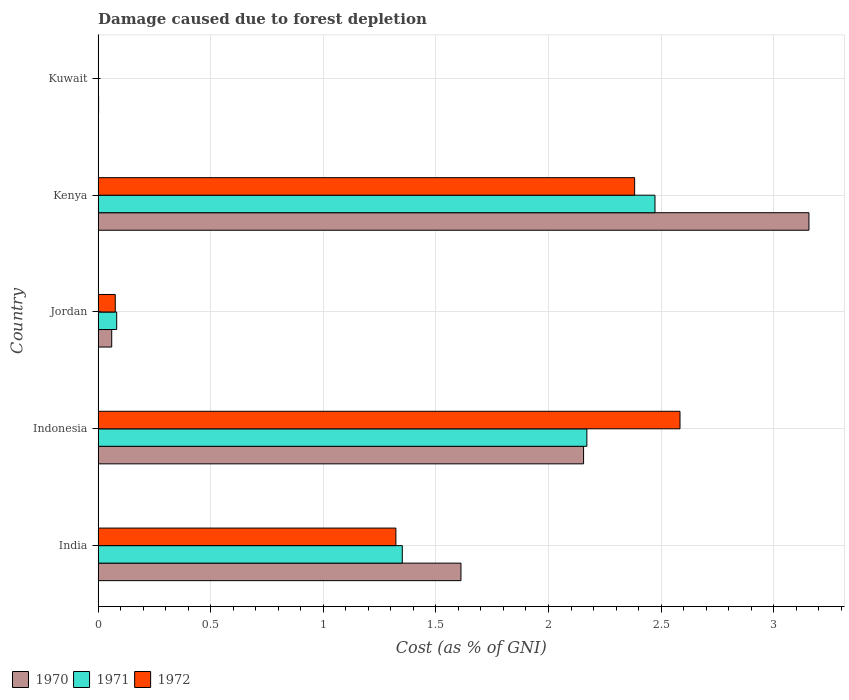How many different coloured bars are there?
Your answer should be very brief. 3. How many groups of bars are there?
Give a very brief answer. 5. Are the number of bars per tick equal to the number of legend labels?
Your answer should be very brief. Yes. Are the number of bars on each tick of the Y-axis equal?
Ensure brevity in your answer.  Yes. What is the label of the 2nd group of bars from the top?
Give a very brief answer. Kenya. What is the cost of damage caused due to forest depletion in 1971 in India?
Your answer should be very brief. 1.35. Across all countries, what is the maximum cost of damage caused due to forest depletion in 1972?
Give a very brief answer. 2.58. Across all countries, what is the minimum cost of damage caused due to forest depletion in 1971?
Your answer should be very brief. 0. In which country was the cost of damage caused due to forest depletion in 1970 maximum?
Provide a succinct answer. Kenya. In which country was the cost of damage caused due to forest depletion in 1971 minimum?
Offer a very short reply. Kuwait. What is the total cost of damage caused due to forest depletion in 1970 in the graph?
Your answer should be very brief. 6.99. What is the difference between the cost of damage caused due to forest depletion in 1972 in Jordan and that in Kuwait?
Your answer should be very brief. 0.07. What is the difference between the cost of damage caused due to forest depletion in 1971 in Kuwait and the cost of damage caused due to forest depletion in 1970 in Indonesia?
Offer a very short reply. -2.15. What is the average cost of damage caused due to forest depletion in 1972 per country?
Provide a succinct answer. 1.27. What is the difference between the cost of damage caused due to forest depletion in 1970 and cost of damage caused due to forest depletion in 1971 in Kuwait?
Ensure brevity in your answer.  0. What is the ratio of the cost of damage caused due to forest depletion in 1970 in India to that in Kenya?
Ensure brevity in your answer.  0.51. Is the cost of damage caused due to forest depletion in 1970 in Indonesia less than that in Jordan?
Provide a short and direct response. No. Is the difference between the cost of damage caused due to forest depletion in 1970 in Jordan and Kuwait greater than the difference between the cost of damage caused due to forest depletion in 1971 in Jordan and Kuwait?
Provide a short and direct response. No. What is the difference between the highest and the second highest cost of damage caused due to forest depletion in 1972?
Give a very brief answer. 0.2. What is the difference between the highest and the lowest cost of damage caused due to forest depletion in 1970?
Offer a terse response. 3.15. In how many countries, is the cost of damage caused due to forest depletion in 1970 greater than the average cost of damage caused due to forest depletion in 1970 taken over all countries?
Offer a terse response. 3. What does the 1st bar from the top in Kenya represents?
Keep it short and to the point. 1972. What does the 3rd bar from the bottom in Indonesia represents?
Offer a very short reply. 1972. How many bars are there?
Provide a short and direct response. 15. How many countries are there in the graph?
Offer a terse response. 5. Does the graph contain any zero values?
Keep it short and to the point. No. Does the graph contain grids?
Your answer should be very brief. Yes. Where does the legend appear in the graph?
Offer a very short reply. Bottom left. How many legend labels are there?
Provide a succinct answer. 3. What is the title of the graph?
Your answer should be compact. Damage caused due to forest depletion. What is the label or title of the X-axis?
Offer a terse response. Cost (as % of GNI). What is the label or title of the Y-axis?
Provide a succinct answer. Country. What is the Cost (as % of GNI) of 1970 in India?
Your answer should be compact. 1.61. What is the Cost (as % of GNI) of 1971 in India?
Your answer should be compact. 1.35. What is the Cost (as % of GNI) of 1972 in India?
Provide a short and direct response. 1.32. What is the Cost (as % of GNI) in 1970 in Indonesia?
Your answer should be compact. 2.16. What is the Cost (as % of GNI) in 1971 in Indonesia?
Offer a terse response. 2.17. What is the Cost (as % of GNI) in 1972 in Indonesia?
Offer a very short reply. 2.58. What is the Cost (as % of GNI) in 1970 in Jordan?
Your answer should be compact. 0.06. What is the Cost (as % of GNI) in 1971 in Jordan?
Your answer should be very brief. 0.08. What is the Cost (as % of GNI) of 1972 in Jordan?
Make the answer very short. 0.08. What is the Cost (as % of GNI) in 1970 in Kenya?
Provide a short and direct response. 3.16. What is the Cost (as % of GNI) in 1971 in Kenya?
Provide a succinct answer. 2.47. What is the Cost (as % of GNI) of 1972 in Kenya?
Provide a short and direct response. 2.38. What is the Cost (as % of GNI) of 1970 in Kuwait?
Ensure brevity in your answer.  0. What is the Cost (as % of GNI) of 1971 in Kuwait?
Your response must be concise. 0. What is the Cost (as % of GNI) in 1972 in Kuwait?
Provide a short and direct response. 0. Across all countries, what is the maximum Cost (as % of GNI) in 1970?
Keep it short and to the point. 3.16. Across all countries, what is the maximum Cost (as % of GNI) of 1971?
Offer a terse response. 2.47. Across all countries, what is the maximum Cost (as % of GNI) of 1972?
Give a very brief answer. 2.58. Across all countries, what is the minimum Cost (as % of GNI) in 1970?
Ensure brevity in your answer.  0. Across all countries, what is the minimum Cost (as % of GNI) of 1971?
Offer a terse response. 0. Across all countries, what is the minimum Cost (as % of GNI) of 1972?
Make the answer very short. 0. What is the total Cost (as % of GNI) of 1970 in the graph?
Keep it short and to the point. 6.99. What is the total Cost (as % of GNI) in 1971 in the graph?
Offer a very short reply. 6.08. What is the total Cost (as % of GNI) in 1972 in the graph?
Provide a short and direct response. 6.37. What is the difference between the Cost (as % of GNI) in 1970 in India and that in Indonesia?
Your answer should be compact. -0.54. What is the difference between the Cost (as % of GNI) of 1971 in India and that in Indonesia?
Your answer should be very brief. -0.82. What is the difference between the Cost (as % of GNI) of 1972 in India and that in Indonesia?
Offer a terse response. -1.26. What is the difference between the Cost (as % of GNI) of 1970 in India and that in Jordan?
Your answer should be very brief. 1.55. What is the difference between the Cost (as % of GNI) of 1971 in India and that in Jordan?
Your answer should be compact. 1.27. What is the difference between the Cost (as % of GNI) of 1972 in India and that in Jordan?
Offer a very short reply. 1.25. What is the difference between the Cost (as % of GNI) in 1970 in India and that in Kenya?
Offer a terse response. -1.55. What is the difference between the Cost (as % of GNI) in 1971 in India and that in Kenya?
Make the answer very short. -1.12. What is the difference between the Cost (as % of GNI) of 1972 in India and that in Kenya?
Make the answer very short. -1.06. What is the difference between the Cost (as % of GNI) of 1970 in India and that in Kuwait?
Your answer should be very brief. 1.61. What is the difference between the Cost (as % of GNI) in 1971 in India and that in Kuwait?
Your answer should be very brief. 1.35. What is the difference between the Cost (as % of GNI) in 1972 in India and that in Kuwait?
Provide a succinct answer. 1.32. What is the difference between the Cost (as % of GNI) of 1970 in Indonesia and that in Jordan?
Ensure brevity in your answer.  2.1. What is the difference between the Cost (as % of GNI) of 1971 in Indonesia and that in Jordan?
Provide a succinct answer. 2.09. What is the difference between the Cost (as % of GNI) in 1972 in Indonesia and that in Jordan?
Make the answer very short. 2.51. What is the difference between the Cost (as % of GNI) of 1970 in Indonesia and that in Kenya?
Ensure brevity in your answer.  -1. What is the difference between the Cost (as % of GNI) in 1971 in Indonesia and that in Kenya?
Keep it short and to the point. -0.3. What is the difference between the Cost (as % of GNI) of 1972 in Indonesia and that in Kenya?
Your answer should be very brief. 0.2. What is the difference between the Cost (as % of GNI) in 1970 in Indonesia and that in Kuwait?
Offer a very short reply. 2.15. What is the difference between the Cost (as % of GNI) in 1971 in Indonesia and that in Kuwait?
Offer a very short reply. 2.17. What is the difference between the Cost (as % of GNI) of 1972 in Indonesia and that in Kuwait?
Offer a terse response. 2.58. What is the difference between the Cost (as % of GNI) in 1970 in Jordan and that in Kenya?
Provide a short and direct response. -3.1. What is the difference between the Cost (as % of GNI) of 1971 in Jordan and that in Kenya?
Provide a short and direct response. -2.39. What is the difference between the Cost (as % of GNI) in 1972 in Jordan and that in Kenya?
Keep it short and to the point. -2.31. What is the difference between the Cost (as % of GNI) in 1970 in Jordan and that in Kuwait?
Your answer should be compact. 0.06. What is the difference between the Cost (as % of GNI) of 1971 in Jordan and that in Kuwait?
Give a very brief answer. 0.08. What is the difference between the Cost (as % of GNI) in 1972 in Jordan and that in Kuwait?
Provide a short and direct response. 0.07. What is the difference between the Cost (as % of GNI) in 1970 in Kenya and that in Kuwait?
Your answer should be compact. 3.15. What is the difference between the Cost (as % of GNI) of 1971 in Kenya and that in Kuwait?
Your answer should be very brief. 2.47. What is the difference between the Cost (as % of GNI) in 1972 in Kenya and that in Kuwait?
Offer a very short reply. 2.38. What is the difference between the Cost (as % of GNI) of 1970 in India and the Cost (as % of GNI) of 1971 in Indonesia?
Provide a succinct answer. -0.56. What is the difference between the Cost (as % of GNI) of 1970 in India and the Cost (as % of GNI) of 1972 in Indonesia?
Provide a succinct answer. -0.97. What is the difference between the Cost (as % of GNI) of 1971 in India and the Cost (as % of GNI) of 1972 in Indonesia?
Keep it short and to the point. -1.23. What is the difference between the Cost (as % of GNI) in 1970 in India and the Cost (as % of GNI) in 1971 in Jordan?
Offer a very short reply. 1.53. What is the difference between the Cost (as % of GNI) of 1970 in India and the Cost (as % of GNI) of 1972 in Jordan?
Your answer should be compact. 1.54. What is the difference between the Cost (as % of GNI) in 1971 in India and the Cost (as % of GNI) in 1972 in Jordan?
Offer a very short reply. 1.27. What is the difference between the Cost (as % of GNI) in 1970 in India and the Cost (as % of GNI) in 1971 in Kenya?
Your response must be concise. -0.86. What is the difference between the Cost (as % of GNI) of 1970 in India and the Cost (as % of GNI) of 1972 in Kenya?
Offer a very short reply. -0.77. What is the difference between the Cost (as % of GNI) of 1971 in India and the Cost (as % of GNI) of 1972 in Kenya?
Provide a short and direct response. -1.03. What is the difference between the Cost (as % of GNI) in 1970 in India and the Cost (as % of GNI) in 1971 in Kuwait?
Ensure brevity in your answer.  1.61. What is the difference between the Cost (as % of GNI) in 1970 in India and the Cost (as % of GNI) in 1972 in Kuwait?
Keep it short and to the point. 1.61. What is the difference between the Cost (as % of GNI) of 1971 in India and the Cost (as % of GNI) of 1972 in Kuwait?
Keep it short and to the point. 1.35. What is the difference between the Cost (as % of GNI) of 1970 in Indonesia and the Cost (as % of GNI) of 1971 in Jordan?
Your answer should be very brief. 2.07. What is the difference between the Cost (as % of GNI) of 1970 in Indonesia and the Cost (as % of GNI) of 1972 in Jordan?
Make the answer very short. 2.08. What is the difference between the Cost (as % of GNI) of 1971 in Indonesia and the Cost (as % of GNI) of 1972 in Jordan?
Make the answer very short. 2.09. What is the difference between the Cost (as % of GNI) of 1970 in Indonesia and the Cost (as % of GNI) of 1971 in Kenya?
Provide a short and direct response. -0.32. What is the difference between the Cost (as % of GNI) of 1970 in Indonesia and the Cost (as % of GNI) of 1972 in Kenya?
Ensure brevity in your answer.  -0.23. What is the difference between the Cost (as % of GNI) of 1971 in Indonesia and the Cost (as % of GNI) of 1972 in Kenya?
Your response must be concise. -0.21. What is the difference between the Cost (as % of GNI) of 1970 in Indonesia and the Cost (as % of GNI) of 1971 in Kuwait?
Your response must be concise. 2.15. What is the difference between the Cost (as % of GNI) in 1970 in Indonesia and the Cost (as % of GNI) in 1972 in Kuwait?
Your answer should be compact. 2.15. What is the difference between the Cost (as % of GNI) in 1971 in Indonesia and the Cost (as % of GNI) in 1972 in Kuwait?
Ensure brevity in your answer.  2.17. What is the difference between the Cost (as % of GNI) of 1970 in Jordan and the Cost (as % of GNI) of 1971 in Kenya?
Keep it short and to the point. -2.41. What is the difference between the Cost (as % of GNI) in 1970 in Jordan and the Cost (as % of GNI) in 1972 in Kenya?
Provide a short and direct response. -2.32. What is the difference between the Cost (as % of GNI) of 1971 in Jordan and the Cost (as % of GNI) of 1972 in Kenya?
Provide a short and direct response. -2.3. What is the difference between the Cost (as % of GNI) of 1970 in Jordan and the Cost (as % of GNI) of 1971 in Kuwait?
Ensure brevity in your answer.  0.06. What is the difference between the Cost (as % of GNI) of 1970 in Jordan and the Cost (as % of GNI) of 1972 in Kuwait?
Your answer should be very brief. 0.06. What is the difference between the Cost (as % of GNI) in 1971 in Jordan and the Cost (as % of GNI) in 1972 in Kuwait?
Provide a short and direct response. 0.08. What is the difference between the Cost (as % of GNI) of 1970 in Kenya and the Cost (as % of GNI) of 1971 in Kuwait?
Your response must be concise. 3.16. What is the difference between the Cost (as % of GNI) of 1970 in Kenya and the Cost (as % of GNI) of 1972 in Kuwait?
Provide a short and direct response. 3.16. What is the difference between the Cost (as % of GNI) in 1971 in Kenya and the Cost (as % of GNI) in 1972 in Kuwait?
Offer a terse response. 2.47. What is the average Cost (as % of GNI) of 1970 per country?
Ensure brevity in your answer.  1.4. What is the average Cost (as % of GNI) of 1971 per country?
Ensure brevity in your answer.  1.22. What is the average Cost (as % of GNI) in 1972 per country?
Offer a very short reply. 1.27. What is the difference between the Cost (as % of GNI) in 1970 and Cost (as % of GNI) in 1971 in India?
Your response must be concise. 0.26. What is the difference between the Cost (as % of GNI) of 1970 and Cost (as % of GNI) of 1972 in India?
Offer a very short reply. 0.29. What is the difference between the Cost (as % of GNI) in 1971 and Cost (as % of GNI) in 1972 in India?
Offer a terse response. 0.03. What is the difference between the Cost (as % of GNI) of 1970 and Cost (as % of GNI) of 1971 in Indonesia?
Keep it short and to the point. -0.01. What is the difference between the Cost (as % of GNI) of 1970 and Cost (as % of GNI) of 1972 in Indonesia?
Offer a terse response. -0.43. What is the difference between the Cost (as % of GNI) in 1971 and Cost (as % of GNI) in 1972 in Indonesia?
Your response must be concise. -0.41. What is the difference between the Cost (as % of GNI) of 1970 and Cost (as % of GNI) of 1971 in Jordan?
Your response must be concise. -0.02. What is the difference between the Cost (as % of GNI) of 1970 and Cost (as % of GNI) of 1972 in Jordan?
Make the answer very short. -0.02. What is the difference between the Cost (as % of GNI) in 1971 and Cost (as % of GNI) in 1972 in Jordan?
Your answer should be very brief. 0.01. What is the difference between the Cost (as % of GNI) of 1970 and Cost (as % of GNI) of 1971 in Kenya?
Keep it short and to the point. 0.68. What is the difference between the Cost (as % of GNI) in 1970 and Cost (as % of GNI) in 1972 in Kenya?
Make the answer very short. 0.77. What is the difference between the Cost (as % of GNI) of 1971 and Cost (as % of GNI) of 1972 in Kenya?
Your answer should be compact. 0.09. What is the difference between the Cost (as % of GNI) in 1970 and Cost (as % of GNI) in 1971 in Kuwait?
Your answer should be very brief. 0. What is the difference between the Cost (as % of GNI) in 1970 and Cost (as % of GNI) in 1972 in Kuwait?
Provide a succinct answer. 0. What is the difference between the Cost (as % of GNI) in 1971 and Cost (as % of GNI) in 1972 in Kuwait?
Provide a short and direct response. -0. What is the ratio of the Cost (as % of GNI) in 1970 in India to that in Indonesia?
Ensure brevity in your answer.  0.75. What is the ratio of the Cost (as % of GNI) in 1971 in India to that in Indonesia?
Ensure brevity in your answer.  0.62. What is the ratio of the Cost (as % of GNI) of 1972 in India to that in Indonesia?
Keep it short and to the point. 0.51. What is the ratio of the Cost (as % of GNI) of 1970 in India to that in Jordan?
Your answer should be very brief. 26.69. What is the ratio of the Cost (as % of GNI) of 1971 in India to that in Jordan?
Offer a terse response. 16.38. What is the ratio of the Cost (as % of GNI) of 1972 in India to that in Jordan?
Ensure brevity in your answer.  17.38. What is the ratio of the Cost (as % of GNI) in 1970 in India to that in Kenya?
Provide a short and direct response. 0.51. What is the ratio of the Cost (as % of GNI) in 1971 in India to that in Kenya?
Offer a terse response. 0.55. What is the ratio of the Cost (as % of GNI) in 1972 in India to that in Kenya?
Your answer should be compact. 0.56. What is the ratio of the Cost (as % of GNI) of 1970 in India to that in Kuwait?
Offer a terse response. 785.54. What is the ratio of the Cost (as % of GNI) in 1971 in India to that in Kuwait?
Your answer should be compact. 1121.22. What is the ratio of the Cost (as % of GNI) of 1972 in India to that in Kuwait?
Keep it short and to the point. 1004.21. What is the ratio of the Cost (as % of GNI) of 1970 in Indonesia to that in Jordan?
Give a very brief answer. 35.71. What is the ratio of the Cost (as % of GNI) of 1971 in Indonesia to that in Jordan?
Provide a succinct answer. 26.32. What is the ratio of the Cost (as % of GNI) in 1972 in Indonesia to that in Jordan?
Ensure brevity in your answer.  33.95. What is the ratio of the Cost (as % of GNI) in 1970 in Indonesia to that in Kenya?
Make the answer very short. 0.68. What is the ratio of the Cost (as % of GNI) in 1971 in Indonesia to that in Kenya?
Ensure brevity in your answer.  0.88. What is the ratio of the Cost (as % of GNI) in 1972 in Indonesia to that in Kenya?
Your response must be concise. 1.08. What is the ratio of the Cost (as % of GNI) of 1970 in Indonesia to that in Kuwait?
Give a very brief answer. 1050.97. What is the ratio of the Cost (as % of GNI) of 1971 in Indonesia to that in Kuwait?
Ensure brevity in your answer.  1801.54. What is the ratio of the Cost (as % of GNI) of 1972 in Indonesia to that in Kuwait?
Offer a very short reply. 1962.23. What is the ratio of the Cost (as % of GNI) in 1970 in Jordan to that in Kenya?
Give a very brief answer. 0.02. What is the ratio of the Cost (as % of GNI) of 1971 in Jordan to that in Kenya?
Your response must be concise. 0.03. What is the ratio of the Cost (as % of GNI) in 1972 in Jordan to that in Kenya?
Your response must be concise. 0.03. What is the ratio of the Cost (as % of GNI) in 1970 in Jordan to that in Kuwait?
Your answer should be very brief. 29.43. What is the ratio of the Cost (as % of GNI) in 1971 in Jordan to that in Kuwait?
Offer a very short reply. 68.45. What is the ratio of the Cost (as % of GNI) of 1972 in Jordan to that in Kuwait?
Give a very brief answer. 57.8. What is the ratio of the Cost (as % of GNI) of 1970 in Kenya to that in Kuwait?
Ensure brevity in your answer.  1538.88. What is the ratio of the Cost (as % of GNI) of 1971 in Kenya to that in Kuwait?
Your answer should be very brief. 2052.57. What is the ratio of the Cost (as % of GNI) in 1972 in Kenya to that in Kuwait?
Your answer should be very brief. 1809.3. What is the difference between the highest and the second highest Cost (as % of GNI) of 1971?
Your answer should be very brief. 0.3. What is the difference between the highest and the second highest Cost (as % of GNI) of 1972?
Your response must be concise. 0.2. What is the difference between the highest and the lowest Cost (as % of GNI) in 1970?
Offer a terse response. 3.15. What is the difference between the highest and the lowest Cost (as % of GNI) in 1971?
Your response must be concise. 2.47. What is the difference between the highest and the lowest Cost (as % of GNI) of 1972?
Give a very brief answer. 2.58. 